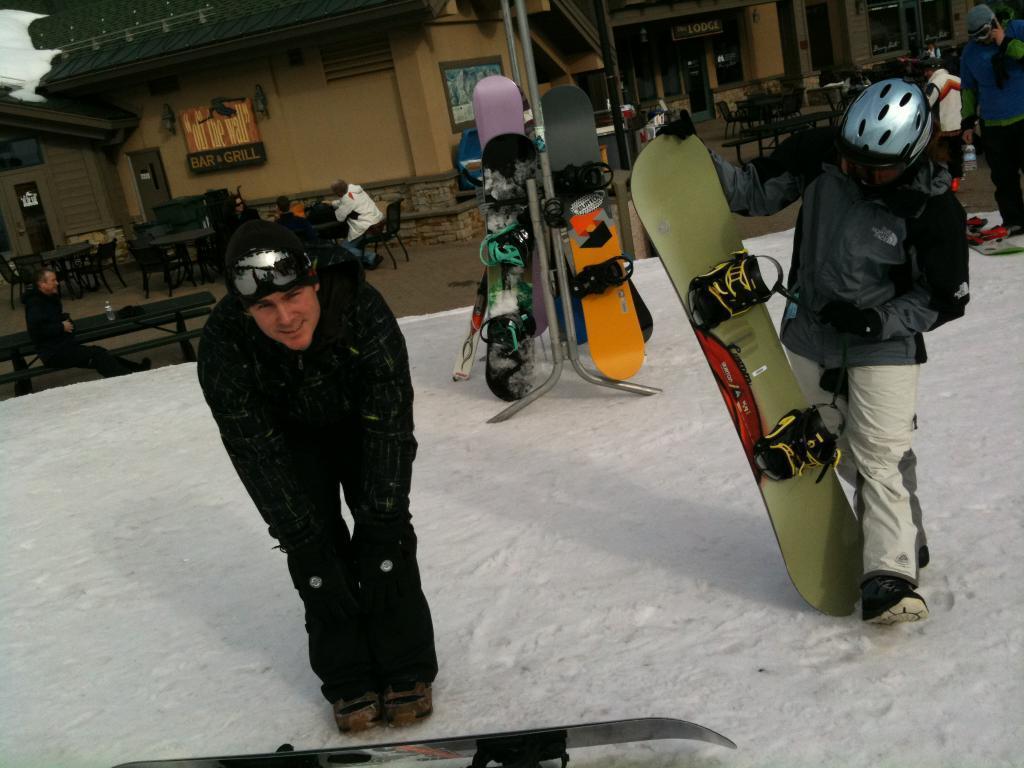Describe this image in one or two sentences. In this image we can see a man standing on the snow, next to him we can see a person holding a ski board. In the background there are skiboards, people and benches. There are people sitting on the chairs and we can see tables and there are sheds. At the bottom there is snow. 